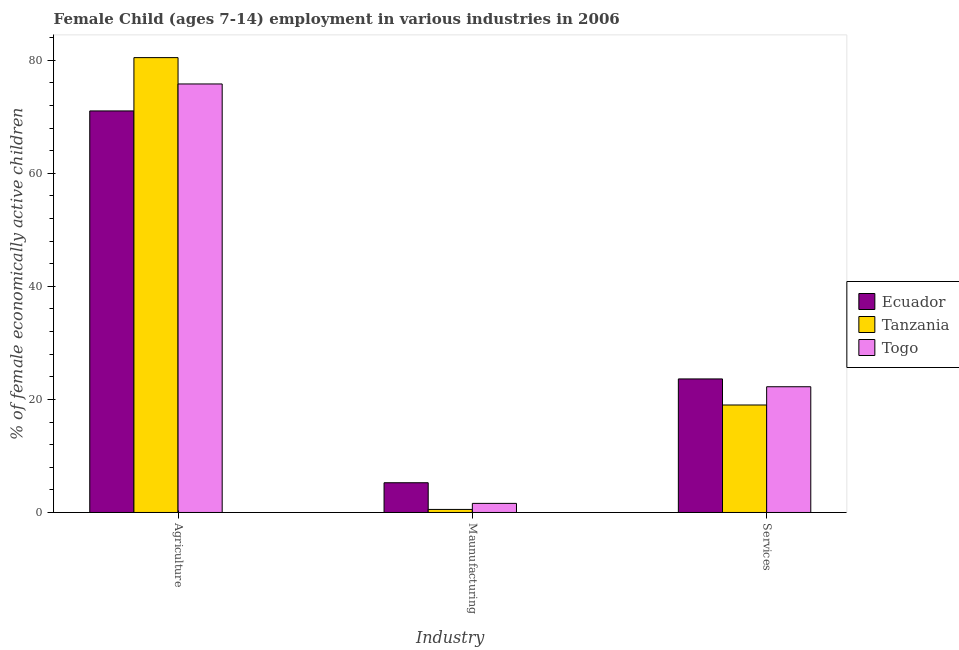How many bars are there on the 2nd tick from the right?
Keep it short and to the point. 3. What is the label of the 1st group of bars from the left?
Your answer should be compact. Agriculture. What is the percentage of economically active children in manufacturing in Togo?
Provide a short and direct response. 1.61. Across all countries, what is the maximum percentage of economically active children in services?
Ensure brevity in your answer.  23.62. Across all countries, what is the minimum percentage of economically active children in services?
Give a very brief answer. 19.01. In which country was the percentage of economically active children in agriculture maximum?
Give a very brief answer. Tanzania. In which country was the percentage of economically active children in services minimum?
Your answer should be compact. Tanzania. What is the total percentage of economically active children in agriculture in the graph?
Offer a terse response. 227.26. What is the difference between the percentage of economically active children in services in Togo and that in Tanzania?
Make the answer very short. 3.23. What is the difference between the percentage of economically active children in services in Togo and the percentage of economically active children in agriculture in Ecuador?
Provide a short and direct response. -48.78. What is the average percentage of economically active children in manufacturing per country?
Your answer should be compact. 2.47. What is the difference between the percentage of economically active children in manufacturing and percentage of economically active children in agriculture in Ecuador?
Make the answer very short. -65.76. In how many countries, is the percentage of economically active children in agriculture greater than 76 %?
Keep it short and to the point. 1. What is the ratio of the percentage of economically active children in services in Ecuador to that in Togo?
Provide a short and direct response. 1.06. Is the percentage of economically active children in services in Tanzania less than that in Ecuador?
Keep it short and to the point. Yes. What is the difference between the highest and the second highest percentage of economically active children in services?
Ensure brevity in your answer.  1.38. What is the difference between the highest and the lowest percentage of economically active children in manufacturing?
Provide a short and direct response. 4.72. In how many countries, is the percentage of economically active children in manufacturing greater than the average percentage of economically active children in manufacturing taken over all countries?
Provide a succinct answer. 1. What does the 1st bar from the left in Agriculture represents?
Make the answer very short. Ecuador. What does the 1st bar from the right in Services represents?
Make the answer very short. Togo. Is it the case that in every country, the sum of the percentage of economically active children in agriculture and percentage of economically active children in manufacturing is greater than the percentage of economically active children in services?
Offer a very short reply. Yes. How many bars are there?
Provide a short and direct response. 9. Are all the bars in the graph horizontal?
Offer a very short reply. No. Are the values on the major ticks of Y-axis written in scientific E-notation?
Keep it short and to the point. No. Does the graph contain grids?
Keep it short and to the point. No. Where does the legend appear in the graph?
Keep it short and to the point. Center right. How are the legend labels stacked?
Your answer should be very brief. Vertical. What is the title of the graph?
Your answer should be compact. Female Child (ages 7-14) employment in various industries in 2006. Does "Kosovo" appear as one of the legend labels in the graph?
Give a very brief answer. No. What is the label or title of the X-axis?
Your response must be concise. Industry. What is the label or title of the Y-axis?
Make the answer very short. % of female economically active children. What is the % of female economically active children in Ecuador in Agriculture?
Your response must be concise. 71.02. What is the % of female economically active children of Tanzania in Agriculture?
Provide a short and direct response. 80.45. What is the % of female economically active children of Togo in Agriculture?
Make the answer very short. 75.79. What is the % of female economically active children in Ecuador in Maunufacturing?
Keep it short and to the point. 5.26. What is the % of female economically active children in Tanzania in Maunufacturing?
Keep it short and to the point. 0.54. What is the % of female economically active children in Togo in Maunufacturing?
Offer a very short reply. 1.61. What is the % of female economically active children in Ecuador in Services?
Keep it short and to the point. 23.62. What is the % of female economically active children in Tanzania in Services?
Give a very brief answer. 19.01. What is the % of female economically active children in Togo in Services?
Give a very brief answer. 22.24. Across all Industry, what is the maximum % of female economically active children in Ecuador?
Ensure brevity in your answer.  71.02. Across all Industry, what is the maximum % of female economically active children in Tanzania?
Give a very brief answer. 80.45. Across all Industry, what is the maximum % of female economically active children of Togo?
Ensure brevity in your answer.  75.79. Across all Industry, what is the minimum % of female economically active children of Ecuador?
Keep it short and to the point. 5.26. Across all Industry, what is the minimum % of female economically active children of Tanzania?
Your answer should be compact. 0.54. Across all Industry, what is the minimum % of female economically active children in Togo?
Provide a succinct answer. 1.61. What is the total % of female economically active children of Ecuador in the graph?
Give a very brief answer. 99.9. What is the total % of female economically active children of Tanzania in the graph?
Ensure brevity in your answer.  100. What is the total % of female economically active children in Togo in the graph?
Ensure brevity in your answer.  99.64. What is the difference between the % of female economically active children of Ecuador in Agriculture and that in Maunufacturing?
Provide a short and direct response. 65.76. What is the difference between the % of female economically active children of Tanzania in Agriculture and that in Maunufacturing?
Provide a succinct answer. 79.91. What is the difference between the % of female economically active children of Togo in Agriculture and that in Maunufacturing?
Your answer should be very brief. 74.18. What is the difference between the % of female economically active children of Ecuador in Agriculture and that in Services?
Provide a succinct answer. 47.4. What is the difference between the % of female economically active children in Tanzania in Agriculture and that in Services?
Keep it short and to the point. 61.44. What is the difference between the % of female economically active children of Togo in Agriculture and that in Services?
Offer a very short reply. 53.55. What is the difference between the % of female economically active children of Ecuador in Maunufacturing and that in Services?
Give a very brief answer. -18.36. What is the difference between the % of female economically active children in Tanzania in Maunufacturing and that in Services?
Your answer should be very brief. -18.47. What is the difference between the % of female economically active children in Togo in Maunufacturing and that in Services?
Your answer should be compact. -20.63. What is the difference between the % of female economically active children in Ecuador in Agriculture and the % of female economically active children in Tanzania in Maunufacturing?
Your answer should be very brief. 70.48. What is the difference between the % of female economically active children in Ecuador in Agriculture and the % of female economically active children in Togo in Maunufacturing?
Ensure brevity in your answer.  69.41. What is the difference between the % of female economically active children of Tanzania in Agriculture and the % of female economically active children of Togo in Maunufacturing?
Your response must be concise. 78.84. What is the difference between the % of female economically active children of Ecuador in Agriculture and the % of female economically active children of Tanzania in Services?
Ensure brevity in your answer.  52.01. What is the difference between the % of female economically active children of Ecuador in Agriculture and the % of female economically active children of Togo in Services?
Keep it short and to the point. 48.78. What is the difference between the % of female economically active children of Tanzania in Agriculture and the % of female economically active children of Togo in Services?
Give a very brief answer. 58.21. What is the difference between the % of female economically active children of Ecuador in Maunufacturing and the % of female economically active children of Tanzania in Services?
Provide a short and direct response. -13.75. What is the difference between the % of female economically active children in Ecuador in Maunufacturing and the % of female economically active children in Togo in Services?
Offer a terse response. -16.98. What is the difference between the % of female economically active children in Tanzania in Maunufacturing and the % of female economically active children in Togo in Services?
Your answer should be compact. -21.7. What is the average % of female economically active children in Ecuador per Industry?
Your response must be concise. 33.3. What is the average % of female economically active children of Tanzania per Industry?
Your answer should be very brief. 33.33. What is the average % of female economically active children in Togo per Industry?
Your answer should be compact. 33.21. What is the difference between the % of female economically active children in Ecuador and % of female economically active children in Tanzania in Agriculture?
Provide a succinct answer. -9.43. What is the difference between the % of female economically active children of Ecuador and % of female economically active children of Togo in Agriculture?
Keep it short and to the point. -4.77. What is the difference between the % of female economically active children of Tanzania and % of female economically active children of Togo in Agriculture?
Make the answer very short. 4.66. What is the difference between the % of female economically active children of Ecuador and % of female economically active children of Tanzania in Maunufacturing?
Ensure brevity in your answer.  4.72. What is the difference between the % of female economically active children of Ecuador and % of female economically active children of Togo in Maunufacturing?
Ensure brevity in your answer.  3.65. What is the difference between the % of female economically active children in Tanzania and % of female economically active children in Togo in Maunufacturing?
Your answer should be compact. -1.07. What is the difference between the % of female economically active children in Ecuador and % of female economically active children in Tanzania in Services?
Keep it short and to the point. 4.61. What is the difference between the % of female economically active children in Ecuador and % of female economically active children in Togo in Services?
Keep it short and to the point. 1.38. What is the difference between the % of female economically active children of Tanzania and % of female economically active children of Togo in Services?
Make the answer very short. -3.23. What is the ratio of the % of female economically active children in Ecuador in Agriculture to that in Maunufacturing?
Your answer should be very brief. 13.5. What is the ratio of the % of female economically active children of Tanzania in Agriculture to that in Maunufacturing?
Keep it short and to the point. 148.98. What is the ratio of the % of female economically active children of Togo in Agriculture to that in Maunufacturing?
Your answer should be compact. 47.07. What is the ratio of the % of female economically active children of Ecuador in Agriculture to that in Services?
Keep it short and to the point. 3.01. What is the ratio of the % of female economically active children in Tanzania in Agriculture to that in Services?
Keep it short and to the point. 4.23. What is the ratio of the % of female economically active children of Togo in Agriculture to that in Services?
Provide a succinct answer. 3.41. What is the ratio of the % of female economically active children of Ecuador in Maunufacturing to that in Services?
Your answer should be compact. 0.22. What is the ratio of the % of female economically active children in Tanzania in Maunufacturing to that in Services?
Your response must be concise. 0.03. What is the ratio of the % of female economically active children in Togo in Maunufacturing to that in Services?
Your answer should be very brief. 0.07. What is the difference between the highest and the second highest % of female economically active children in Ecuador?
Make the answer very short. 47.4. What is the difference between the highest and the second highest % of female economically active children in Tanzania?
Provide a short and direct response. 61.44. What is the difference between the highest and the second highest % of female economically active children in Togo?
Offer a very short reply. 53.55. What is the difference between the highest and the lowest % of female economically active children of Ecuador?
Make the answer very short. 65.76. What is the difference between the highest and the lowest % of female economically active children of Tanzania?
Keep it short and to the point. 79.91. What is the difference between the highest and the lowest % of female economically active children in Togo?
Your response must be concise. 74.18. 